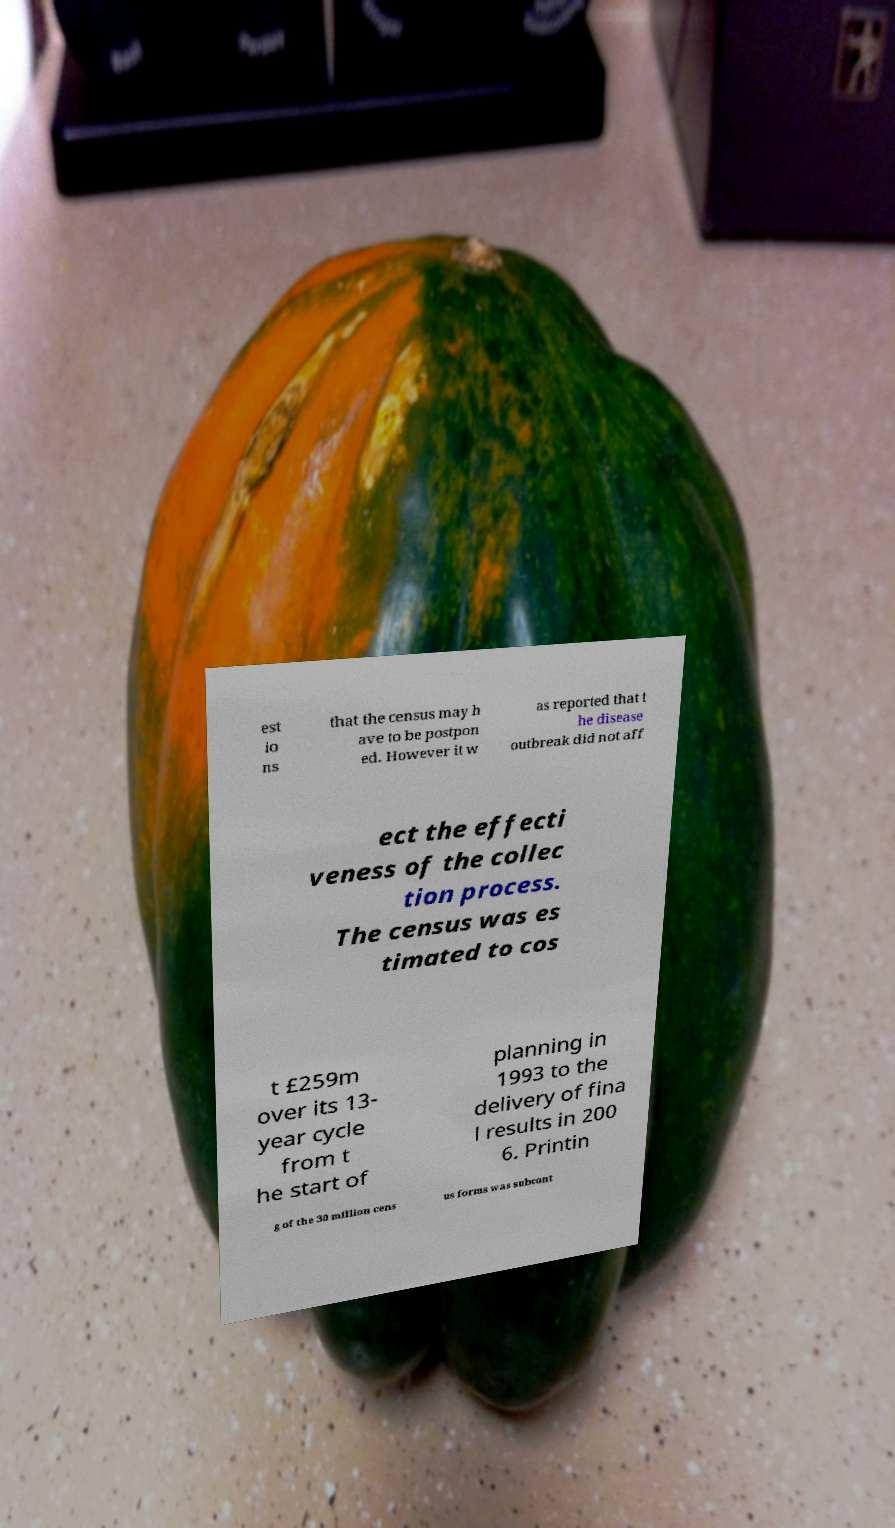I need the written content from this picture converted into text. Can you do that? est io ns that the census may h ave to be postpon ed. However it w as reported that t he disease outbreak did not aff ect the effecti veness of the collec tion process. The census was es timated to cos t £259m over its 13- year cycle from t he start of planning in 1993 to the delivery of fina l results in 200 6. Printin g of the 30 million cens us forms was subcont 